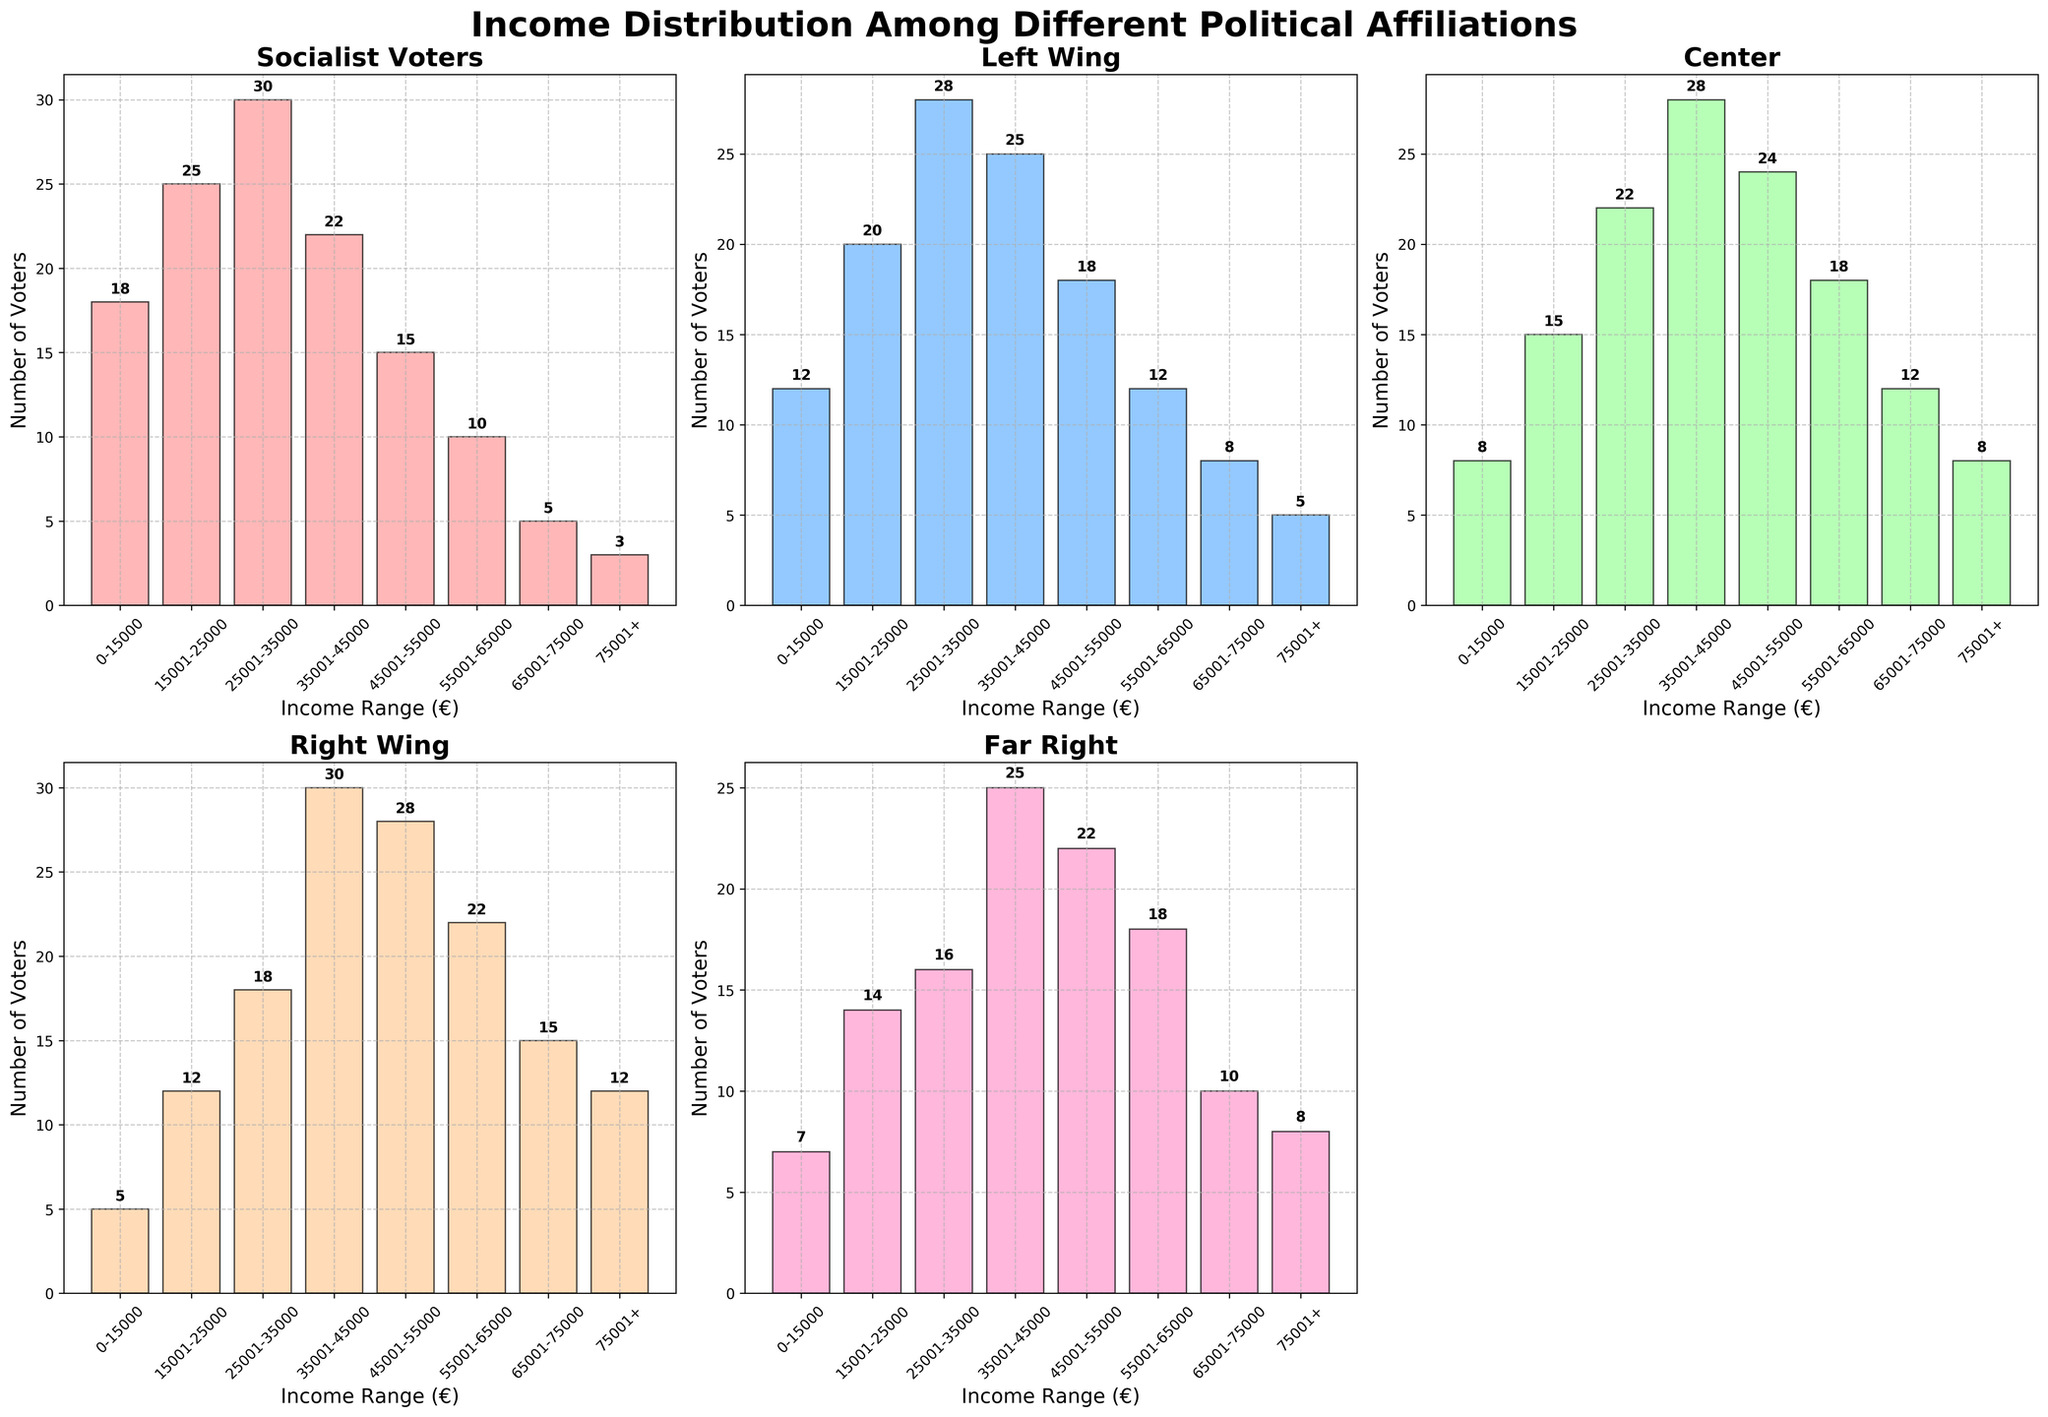What's the title of the figure? The title is clearly displayed at the top of the figure.
Answer: "Income Distribution Among Different Political Affiliations" How many income ranges are shown in each subplot? The x-axis of each subplot categorizes income into defined ranges. Count the number of these categories.
Answer: 8 What's the color used for the bar representing Socialist Voters? The color used for each party is different and can be identified visually from the figure.
Answer: Light Pink (#FF9999) Which political affiliation has the highest number of voters in the 0-15000 income range? Examine the height of the bars for each political affiliation in the 0-15000 income range. The tallest bar represents the highest number of voters.
Answer: Socialist Voters How many Socialist Voters fall within the 25001-35000 income range? Look at the height of the bar representing Socialist Voters within the specified income range and refer to the value annotated on the bar.
Answer: 30 What's the difference in the number of voters in the 35001-45000 income range between Socialist Voters and Right Wing? Identify the values for both political affiliations in the specified income range and subtract the smaller number from the larger one.
Answer: 8 What's the average number of voters in the 55001-65000 income range across all political affiliations? Sum the number of voters in the 55001-65000 income range for all political affiliations, then divide by the number of affiliations (5).
Answer: (10 + 12 + 18 + 22 + 18)/5 = 16 Which income range has the least number of voters for Far Right? Find the bar with the smallest height in the Far Right subplot and check its income range at the x-axis.
Answer: 0-15000 Compare the number of voters in the 65001-75000 income range between Left Wing and Far Right. Which has more and by how much? Compare the heights of the bars for both affiliations within this income range and subtract the smaller number from the larger one.
Answer: Left Wing has 2 more voters What trend can be observed about the distribution of voters as income increases across all political affiliations? By examining the heights of bars from low to high income ranges across all subplots, identify if the number of voters generally increases, decreases, or remains constant.
Answer: Decreases across all affiliations 